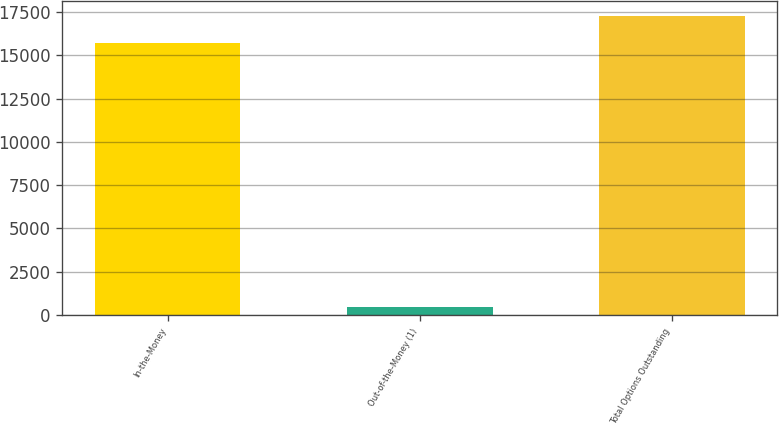Convert chart. <chart><loc_0><loc_0><loc_500><loc_500><bar_chart><fcel>In-the-Money<fcel>Out-of-the-Money (1)<fcel>Total Options Outstanding<nl><fcel>15714<fcel>481<fcel>17285.4<nl></chart> 